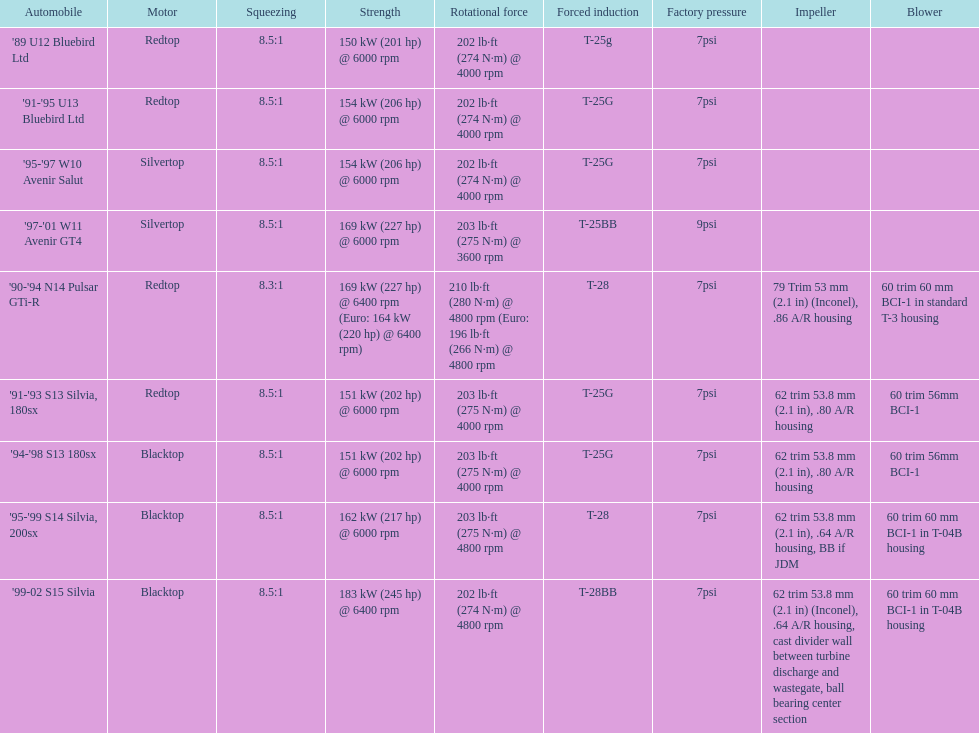Which engines were used after 1999? Silvertop, Blacktop. 